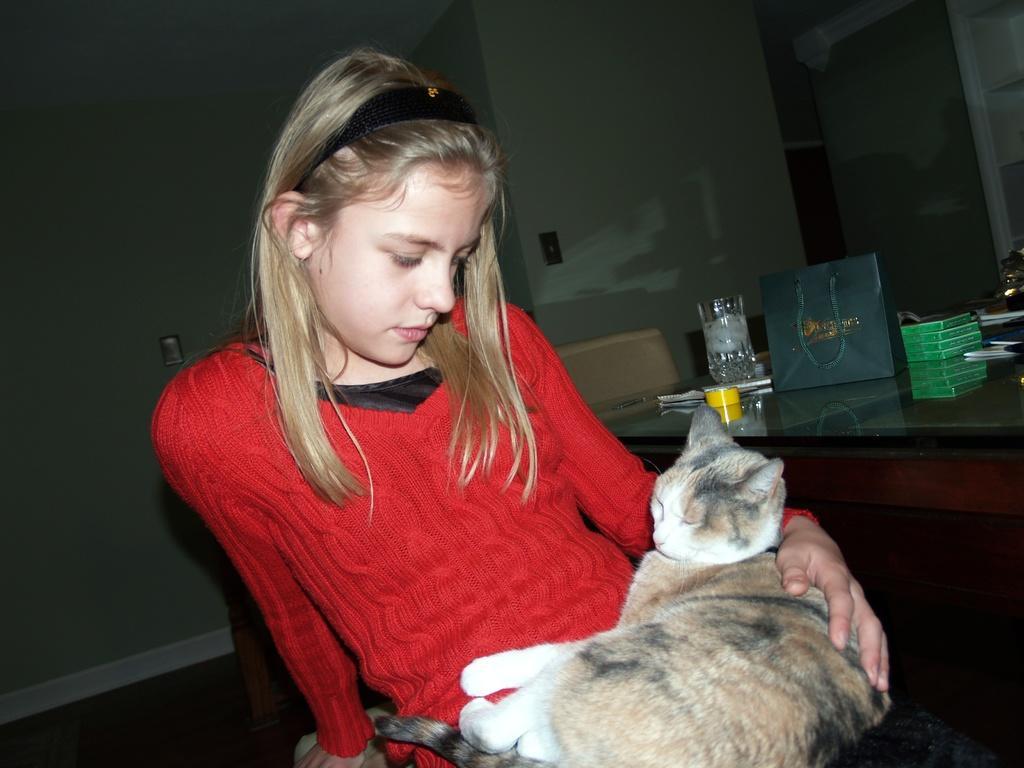In one or two sentences, can you explain what this image depicts? On the background we can see a wall. Here we can see a table and chairs and on the table we can see glass, yellow tape, bag and boxes. Here we can see one girl wearing a red colour shirt with full length sleeves and we can see a cat in her lap. 